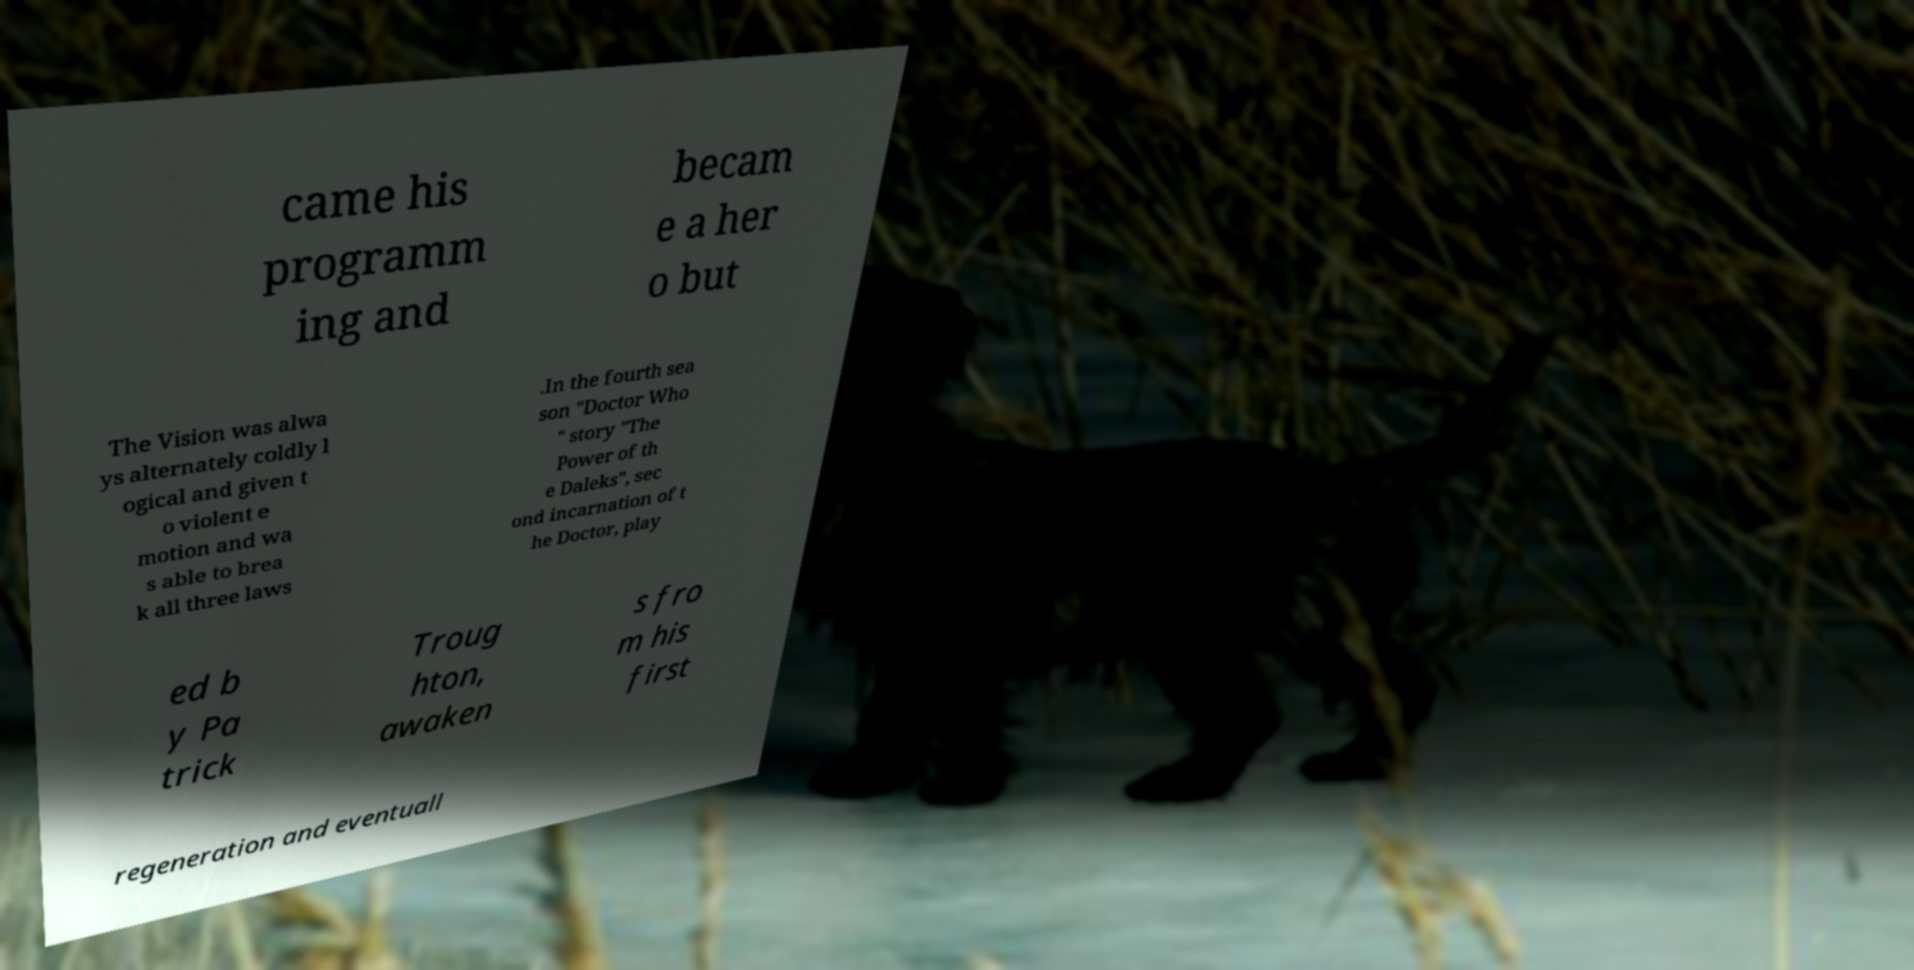Please read and relay the text visible in this image. What does it say? came his programm ing and becam e a her o but The Vision was alwa ys alternately coldly l ogical and given t o violent e motion and wa s able to brea k all three laws .In the fourth sea son "Doctor Who " story "The Power of th e Daleks", sec ond incarnation of t he Doctor, play ed b y Pa trick Troug hton, awaken s fro m his first regeneration and eventuall 